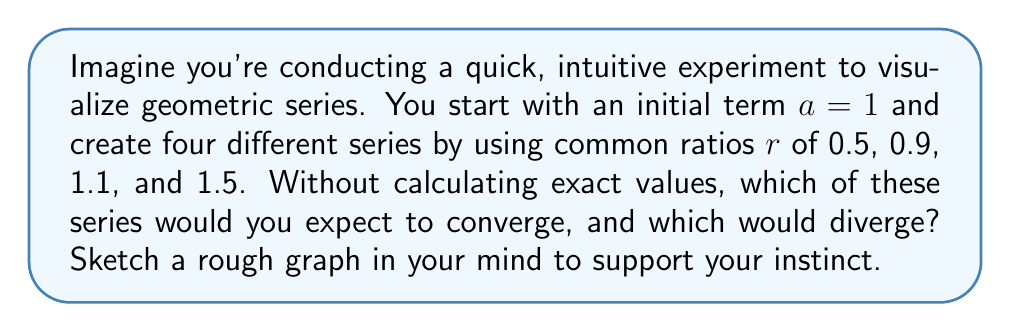Could you help me with this problem? Let's approach this intuitively:

1) For a geometric series $\sum_{n=0}^{\infty} ar^n$, the behavior depends on the common ratio $r$.

2) Visualize each series:

   a) $r = 0.5$: Each term is half the previous one. The series quickly approaches zero.
   
   b) $r = 0.9$: Each term is 90% of the previous one. It decreases, but more slowly.
   
   c) $r = 1.1$: Each term is 10% larger than the previous one. It grows, but not rapidly.
   
   d) $r = 1.5$: Each term is 50% larger than the previous one. It grows quickly.

3) Intuitively, we can see that:
   - Series with $r < 1$ get smaller and approach zero.
   - Series with $r > 1$ keep growing.

4) The general rule is:
   - If $|r| < 1$, the series converges.
   - If $|r| \geq 1$, the series diverges.

5) Therefore:
   - Series with $r = 0.5$ and $r = 0.9$ converge.
   - Series with $r = 1.1$ and $r = 1.5$ diverge.

This aligns with our visual intuition of the series' behavior.
Answer: Converge: $r = 0.5$ and $r = 0.9$
Diverge: $r = 1.1$ and $r = 1.5$ 